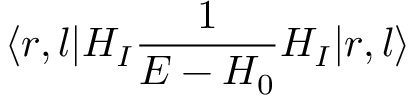<formula> <loc_0><loc_0><loc_500><loc_500>\langle r , l | H _ { I } { \frac { 1 } { E - H _ { 0 } } } H _ { I } | r , l \rangle</formula> 